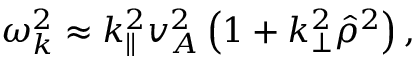<formula> <loc_0><loc_0><loc_500><loc_500>\begin{array} { r } { \omega _ { k } ^ { 2 } \approx k _ { \| } ^ { 2 } v _ { A } ^ { 2 } \left ( 1 + k _ { \perp } ^ { 2 } \hat { \rho } ^ { 2 } \right ) , } \end{array}</formula> 